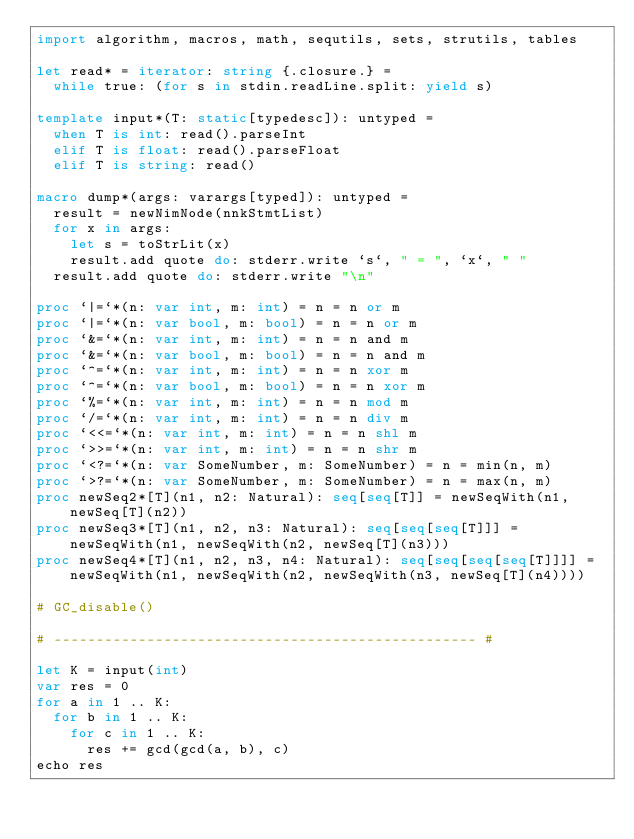Convert code to text. <code><loc_0><loc_0><loc_500><loc_500><_Nim_>import algorithm, macros, math, sequtils, sets, strutils, tables

let read* = iterator: string {.closure.} =
  while true: (for s in stdin.readLine.split: yield s)

template input*(T: static[typedesc]): untyped = 
  when T is int: read().parseInt
  elif T is float: read().parseFloat
  elif T is string: read()

macro dump*(args: varargs[typed]): untyped =
  result = newNimNode(nnkStmtList)
  for x in args:
    let s = toStrLit(x)
    result.add quote do: stderr.write `s`, " = ", `x`, " "
  result.add quote do: stderr.write "\n"

proc `|=`*(n: var int, m: int) = n = n or m
proc `|=`*(n: var bool, m: bool) = n = n or m
proc `&=`*(n: var int, m: int) = n = n and m
proc `&=`*(n: var bool, m: bool) = n = n and m
proc `^=`*(n: var int, m: int) = n = n xor m
proc `^=`*(n: var bool, m: bool) = n = n xor m
proc `%=`*(n: var int, m: int) = n = n mod m
proc `/=`*(n: var int, m: int) = n = n div m
proc `<<=`*(n: var int, m: int) = n = n shl m
proc `>>=`*(n: var int, m: int) = n = n shr m
proc `<?=`*(n: var SomeNumber, m: SomeNumber) = n = min(n, m)
proc `>?=`*(n: var SomeNumber, m: SomeNumber) = n = max(n, m)
proc newSeq2*[T](n1, n2: Natural): seq[seq[T]] = newSeqWith(n1, newSeq[T](n2))
proc newSeq3*[T](n1, n2, n3: Natural): seq[seq[seq[T]]] = newSeqWith(n1, newSeqWith(n2, newSeq[T](n3)))
proc newSeq4*[T](n1, n2, n3, n4: Natural): seq[seq[seq[seq[T]]]] = newSeqWith(n1, newSeqWith(n2, newSeqWith(n3, newSeq[T](n4))))

# GC_disable()

# -------------------------------------------------- #

let K = input(int)
var res = 0
for a in 1 .. K:
  for b in 1 .. K:
    for c in 1 .. K:
      res += gcd(gcd(a, b), c)
echo res
</code> 